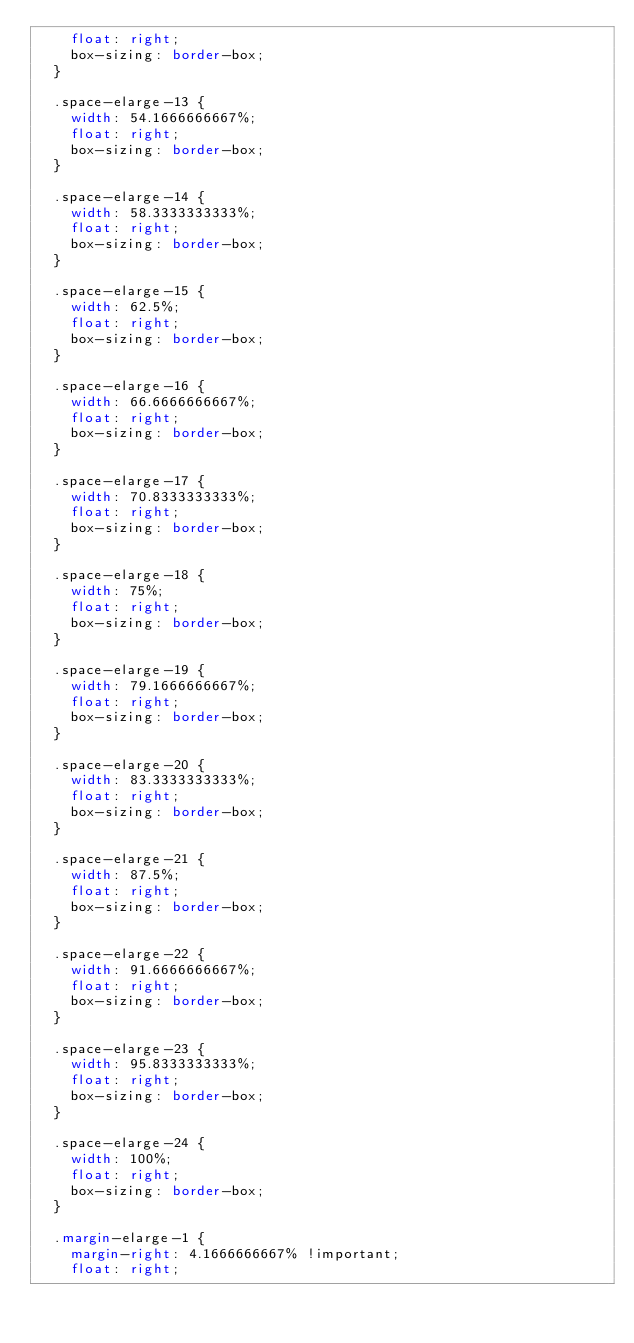<code> <loc_0><loc_0><loc_500><loc_500><_CSS_>    float: right;
    box-sizing: border-box;
  }

  .space-elarge-13 {
    width: 54.1666666667%;
    float: right;
    box-sizing: border-box;
  }

  .space-elarge-14 {
    width: 58.3333333333%;
    float: right;
    box-sizing: border-box;
  }

  .space-elarge-15 {
    width: 62.5%;
    float: right;
    box-sizing: border-box;
  }

  .space-elarge-16 {
    width: 66.6666666667%;
    float: right;
    box-sizing: border-box;
  }

  .space-elarge-17 {
    width: 70.8333333333%;
    float: right;
    box-sizing: border-box;
  }

  .space-elarge-18 {
    width: 75%;
    float: right;
    box-sizing: border-box;
  }

  .space-elarge-19 {
    width: 79.1666666667%;
    float: right;
    box-sizing: border-box;
  }

  .space-elarge-20 {
    width: 83.3333333333%;
    float: right;
    box-sizing: border-box;
  }

  .space-elarge-21 {
    width: 87.5%;
    float: right;
    box-sizing: border-box;
  }

  .space-elarge-22 {
    width: 91.6666666667%;
    float: right;
    box-sizing: border-box;
  }

  .space-elarge-23 {
    width: 95.8333333333%;
    float: right;
    box-sizing: border-box;
  }

  .space-elarge-24 {
    width: 100%;
    float: right;
    box-sizing: border-box;
  }

  .margin-elarge-1 {
    margin-right: 4.1666666667% !important;
    float: right;</code> 